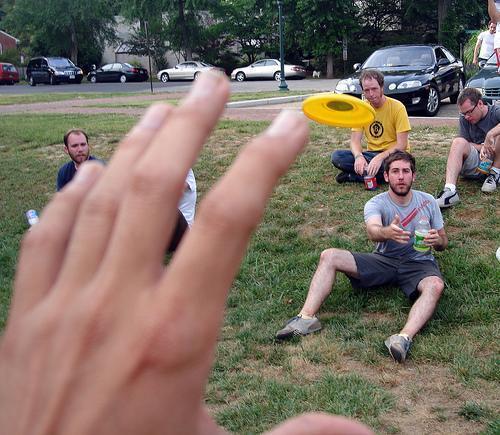How many vehicles are there?
Give a very brief answer. 7. How many people are holding a bottle?
Give a very brief answer. 3. 